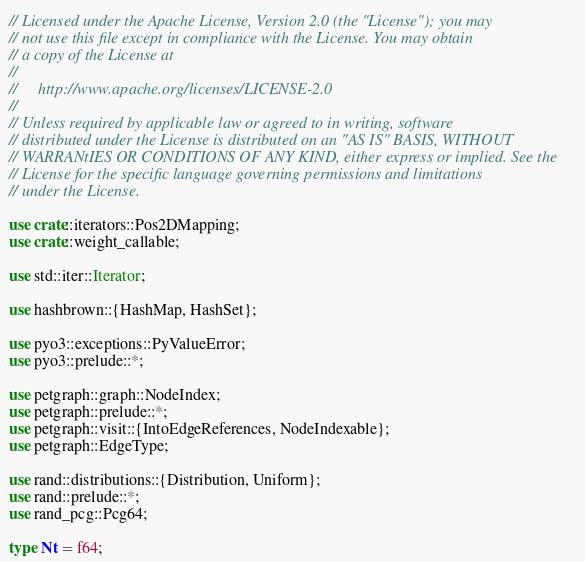Convert code to text. <code><loc_0><loc_0><loc_500><loc_500><_Rust_>// Licensed under the Apache License, Version 2.0 (the "License"); you may
// not use this file except in compliance with the License. You may obtain
// a copy of the License at
//
//     http://www.apache.org/licenses/LICENSE-2.0
//
// Unless required by applicable law or agreed to in writing, software
// distributed under the License is distributed on an "AS IS" BASIS, WITHOUT
// WARRANtIES OR CONDITIONS OF ANY KIND, either express or implied. See the
// License for the specific language governing permissions and limitations
// under the License.

use crate::iterators::Pos2DMapping;
use crate::weight_callable;

use std::iter::Iterator;

use hashbrown::{HashMap, HashSet};

use pyo3::exceptions::PyValueError;
use pyo3::prelude::*;

use petgraph::graph::NodeIndex;
use petgraph::prelude::*;
use petgraph::visit::{IntoEdgeReferences, NodeIndexable};
use petgraph::EdgeType;

use rand::distributions::{Distribution, Uniform};
use rand::prelude::*;
use rand_pcg::Pcg64;

type Nt = f64;</code> 